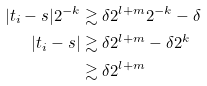<formula> <loc_0><loc_0><loc_500><loc_500>| t _ { i } - s | 2 ^ { - k } & \gtrsim \delta 2 ^ { l + m } 2 ^ { - k } - \delta \\ | t _ { i } - s | & \gtrsim \delta 2 ^ { l + m } - \delta 2 ^ { k } \\ & \gtrsim \delta 2 ^ { l + m }</formula> 